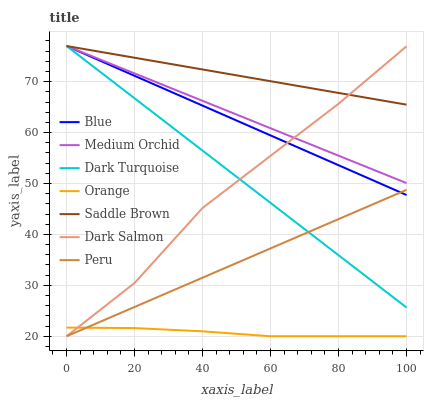Does Orange have the minimum area under the curve?
Answer yes or no. Yes. Does Saddle Brown have the maximum area under the curve?
Answer yes or no. Yes. Does Dark Turquoise have the minimum area under the curve?
Answer yes or no. No. Does Dark Turquoise have the maximum area under the curve?
Answer yes or no. No. Is Peru the smoothest?
Answer yes or no. Yes. Is Dark Salmon the roughest?
Answer yes or no. Yes. Is Dark Turquoise the smoothest?
Answer yes or no. No. Is Dark Turquoise the roughest?
Answer yes or no. No. Does Dark Salmon have the lowest value?
Answer yes or no. Yes. Does Dark Turquoise have the lowest value?
Answer yes or no. No. Does Saddle Brown have the highest value?
Answer yes or no. Yes. Does Dark Salmon have the highest value?
Answer yes or no. No. Is Peru less than Saddle Brown?
Answer yes or no. Yes. Is Medium Orchid greater than Orange?
Answer yes or no. Yes. Does Orange intersect Peru?
Answer yes or no. Yes. Is Orange less than Peru?
Answer yes or no. No. Is Orange greater than Peru?
Answer yes or no. No. Does Peru intersect Saddle Brown?
Answer yes or no. No. 